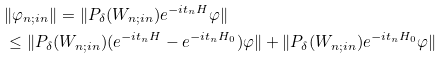<formula> <loc_0><loc_0><loc_500><loc_500>& \| \varphi _ { n ; i n } \| = \| P _ { \delta } ( W _ { n ; i n } ) e ^ { - i t _ { n } H } \varphi \| \\ & \leq \| P _ { \delta } ( W _ { n ; i n } ) ( e ^ { - i t _ { n } H } - e ^ { - i t _ { n } H _ { 0 } } ) \varphi \| + \| P _ { \delta } ( W _ { n ; i n } ) e ^ { - i t _ { n } H _ { 0 } } \varphi \|</formula> 